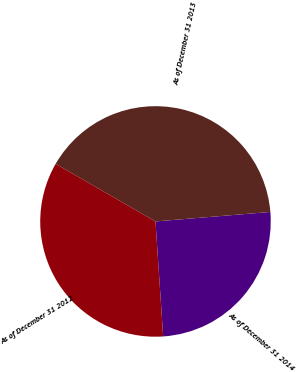<chart> <loc_0><loc_0><loc_500><loc_500><pie_chart><fcel>As of December 31 2014<fcel>As of December 31 2013<fcel>As of December 31 2012<nl><fcel>25.25%<fcel>40.36%<fcel>34.39%<nl></chart> 